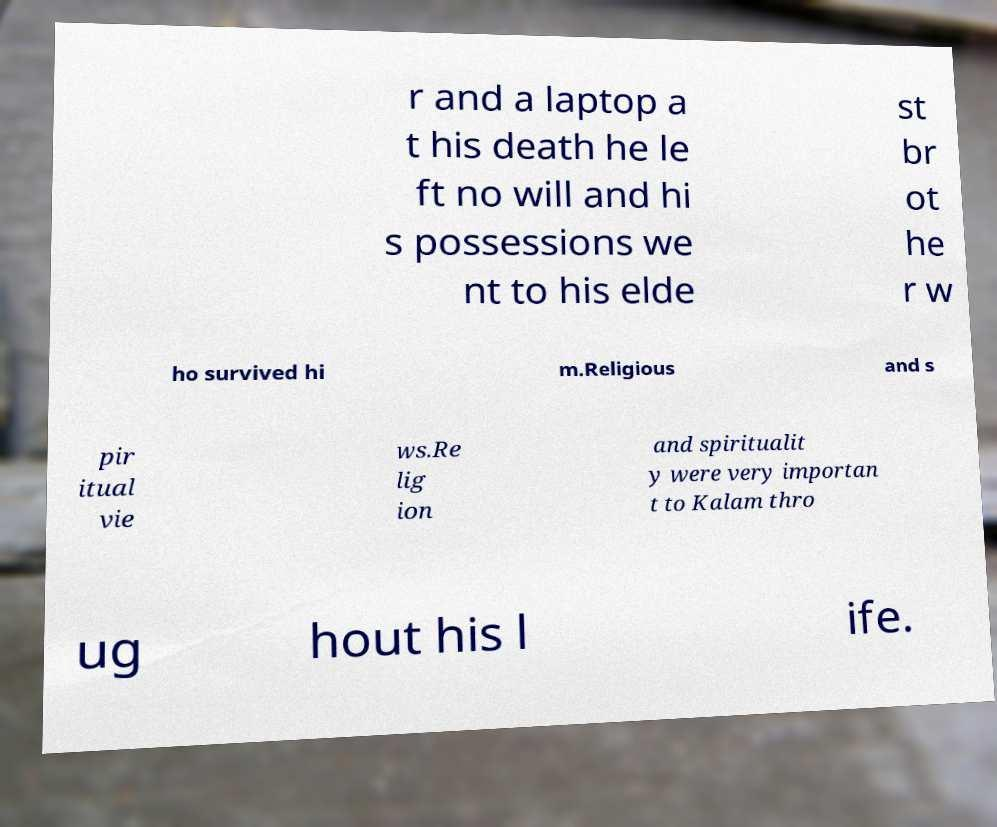For documentation purposes, I need the text within this image transcribed. Could you provide that? r and a laptop a t his death he le ft no will and hi s possessions we nt to his elde st br ot he r w ho survived hi m.Religious and s pir itual vie ws.Re lig ion and spiritualit y were very importan t to Kalam thro ug hout his l ife. 